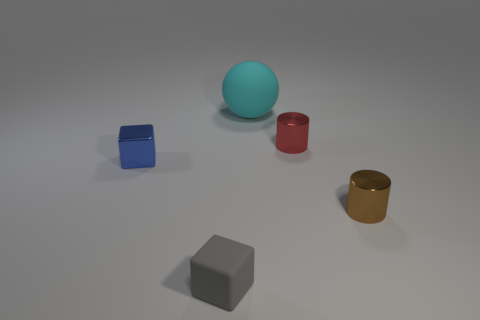Is the material of the small object on the left side of the gray rubber thing the same as the small brown object?
Offer a very short reply. Yes. What number of things are behind the tiny brown shiny cylinder and in front of the large cyan object?
Ensure brevity in your answer.  2. What material is the cyan thing?
Offer a very short reply. Rubber. What is the shape of the blue object that is the same size as the rubber block?
Make the answer very short. Cube. Is the tiny cylinder that is right of the tiny red metal cylinder made of the same material as the cyan object behind the red thing?
Your answer should be compact. No. How many brown objects are the same shape as the tiny gray matte thing?
Provide a short and direct response. 0. Do the gray matte thing and the big object have the same shape?
Offer a very short reply. No. How big is the red metallic thing?
Your answer should be very brief. Small. How many metal cubes are the same size as the brown object?
Provide a short and direct response. 1. Do the shiny cylinder that is behind the blue cube and the matte object behind the small brown shiny object have the same size?
Make the answer very short. No. 